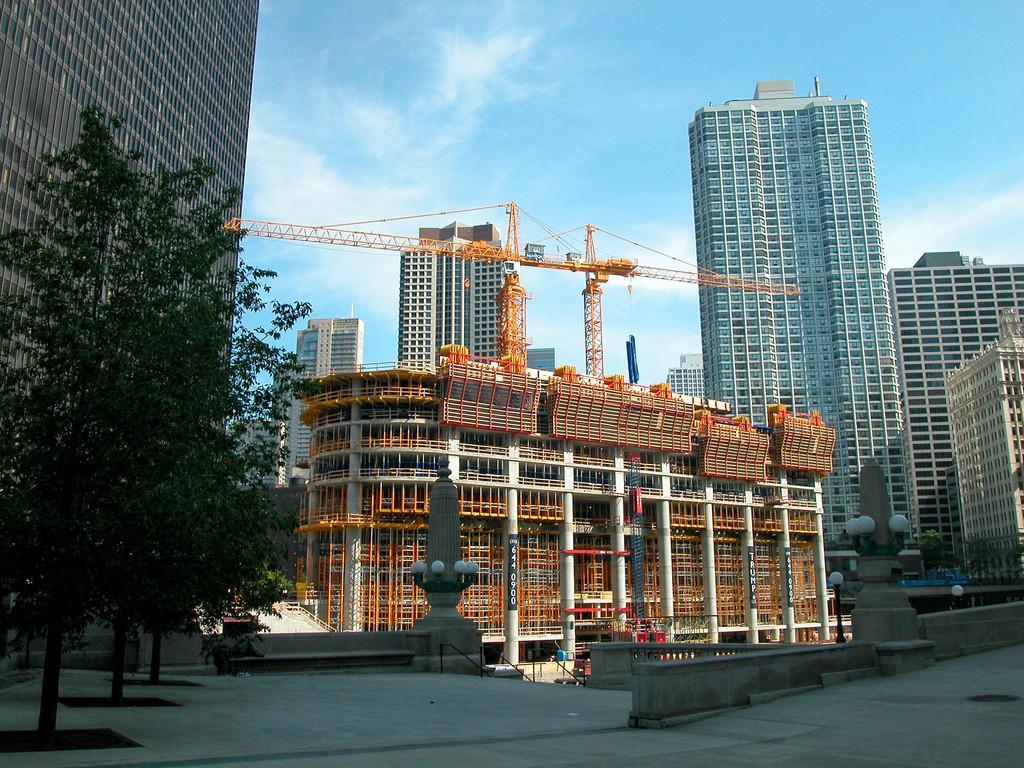Can you describe this image briefly? In this image I can see trees, fence, poles, buildings and metal rods. At the top I can see the blue sky. This image is taken may be on the road. 